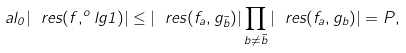<formula> <loc_0><loc_0><loc_500><loc_500>\ a l _ { 0 } | \ r e s ( f , ^ { o } l { g } { 1 } ) | \leq | \ r e s ( f _ { a } , g _ { \bar { b } } ) | \prod _ { b \ne \bar { b } } | \ r e s ( f _ { a } , g _ { b } ) | = P ,</formula> 